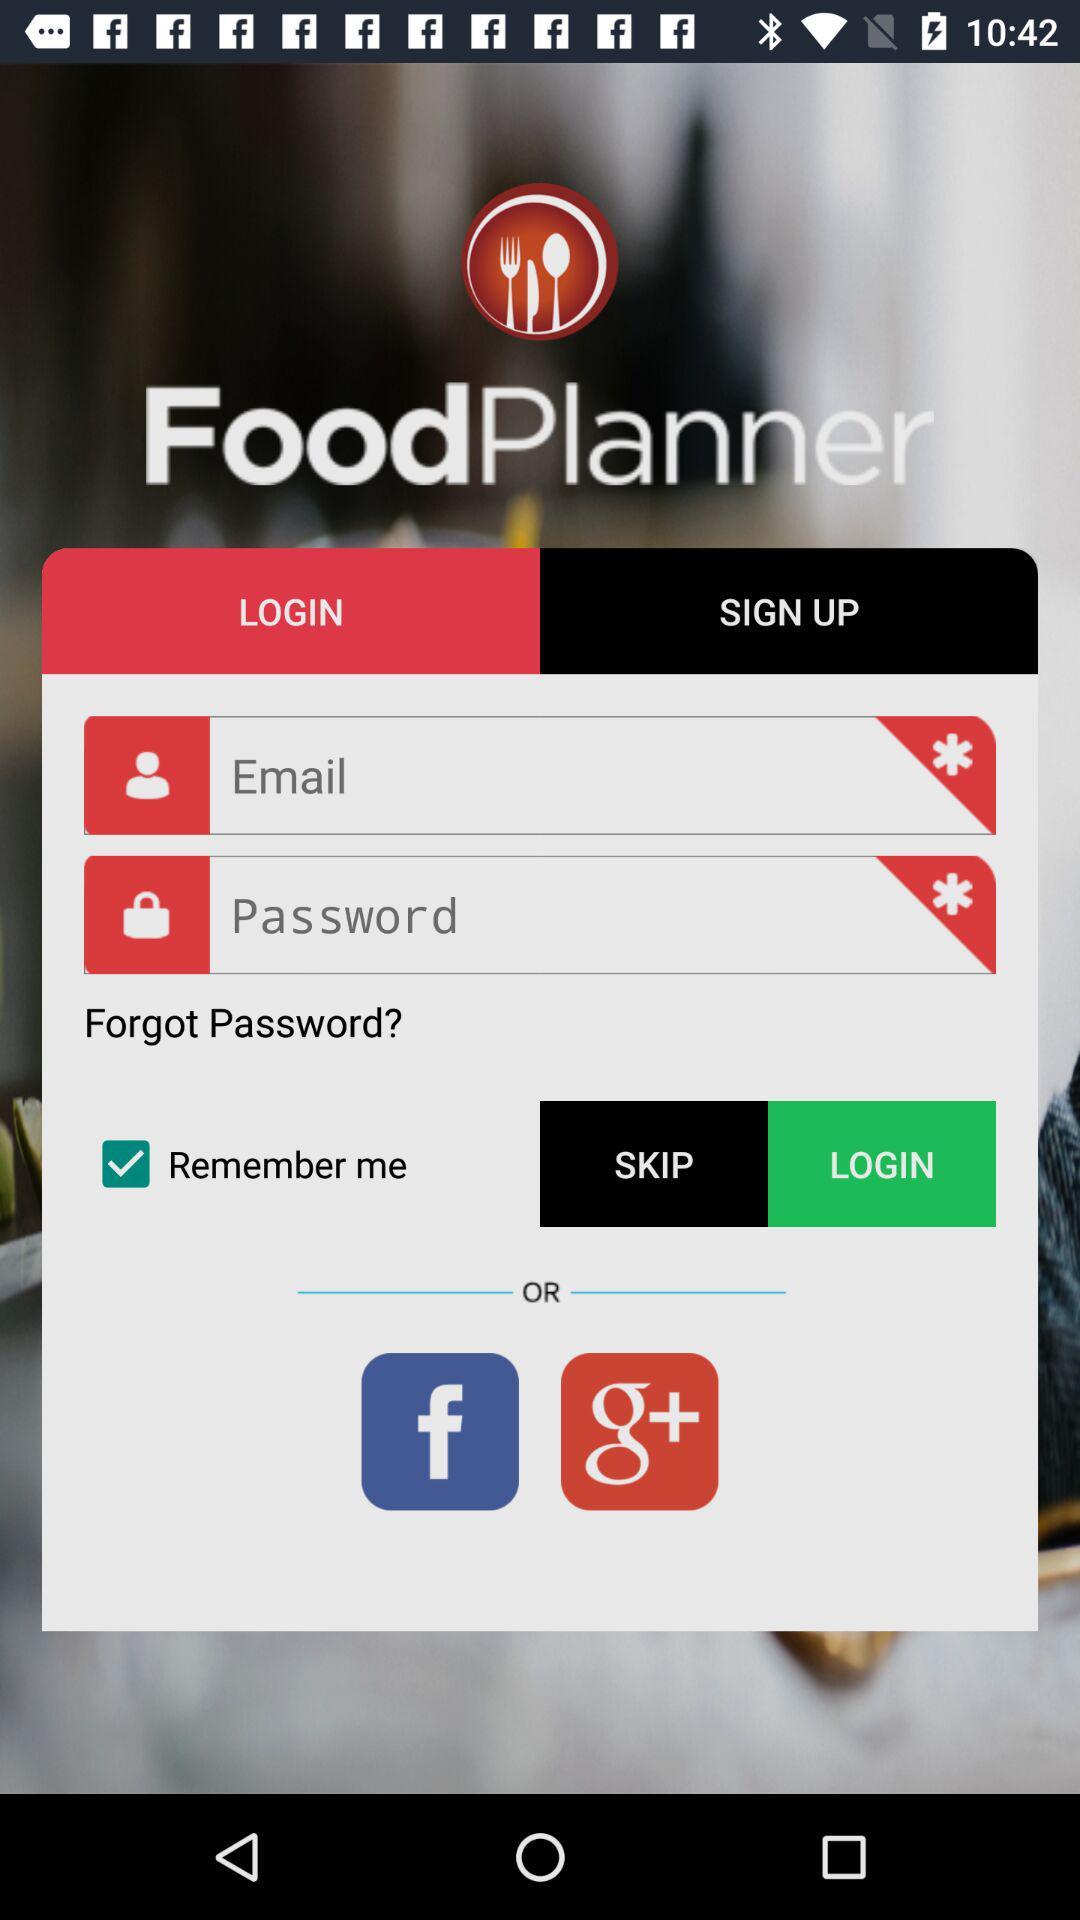What is the status of login in?
When the provided information is insufficient, respond with <no answer>. <no answer> 